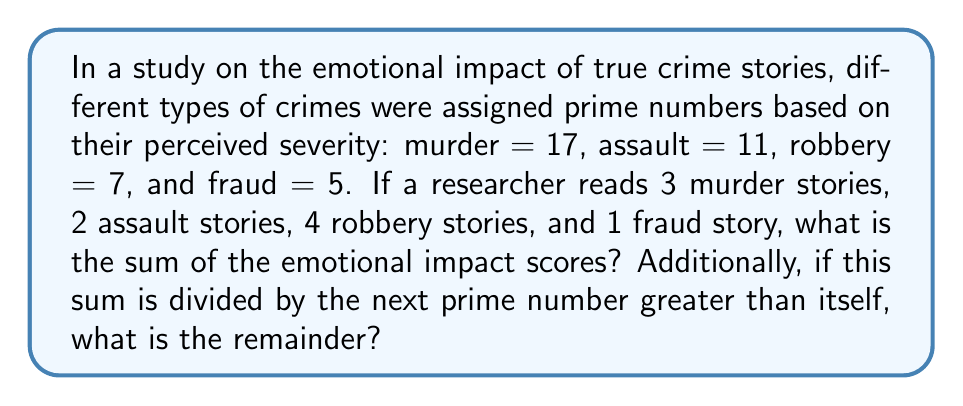Could you help me with this problem? Let's approach this step-by-step:

1) First, we need to calculate the emotional impact score for each crime type:

   Murder: $3 \times 17 = 51$
   Assault: $2 \times 11 = 22$
   Robbery: $4 \times 7 = 28$
   Fraud: $1 \times 5 = 5$

2) Now, we sum these scores:

   $51 + 22 + 28 + 5 = 106$

3) The sum of the emotional impact scores is 106.

4) To find the next prime number greater than 106, we need to check the primality of numbers starting from 107:

   107 is prime (it's only divisible by 1 and itself)

5) Now, we need to divide 106 by 107 and find the remainder:

   $106 \div 107 = 0$ remainder $106$

Therefore, the remainder when 106 is divided by 107 is 106.
Answer: 106, 106 